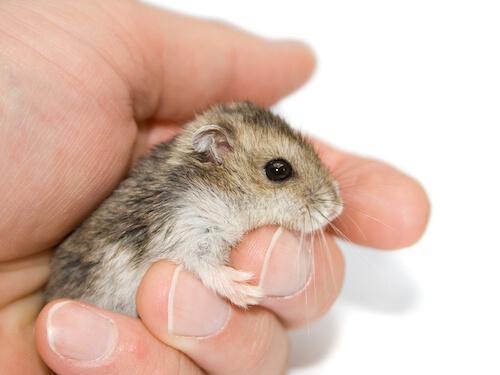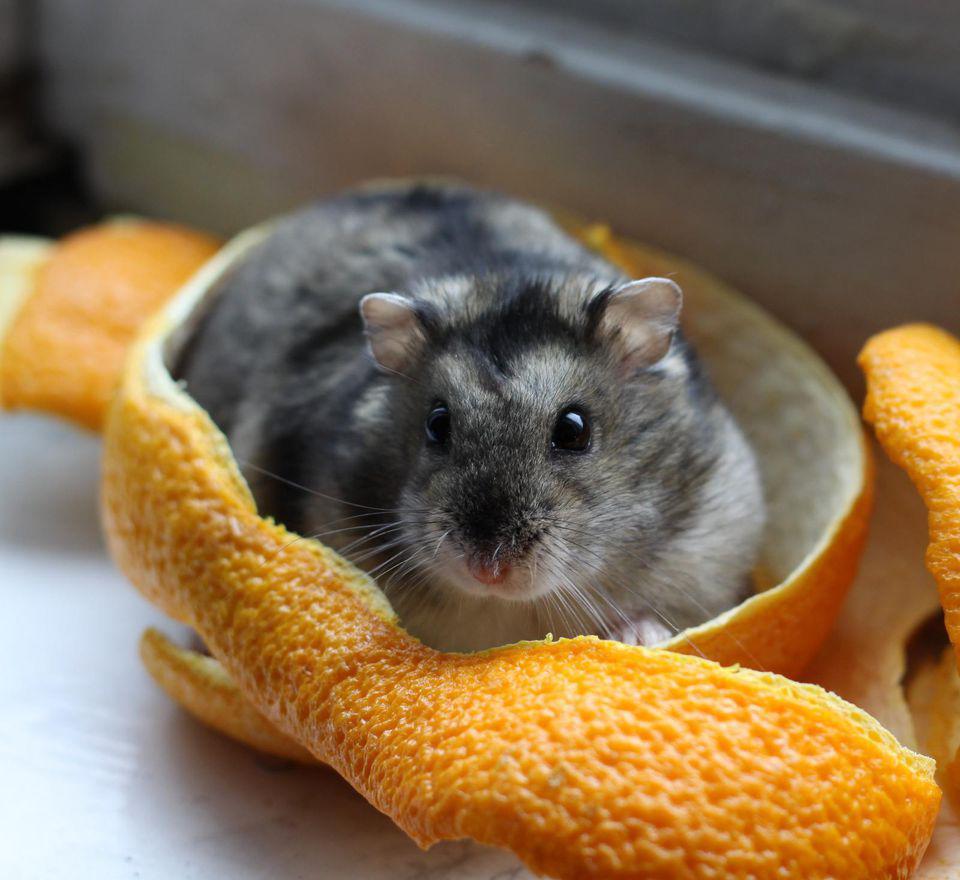The first image is the image on the left, the second image is the image on the right. Given the left and right images, does the statement "A hand is holding multiple hamsters with mottled grayish-brown fir." hold true? Answer yes or no. No. 